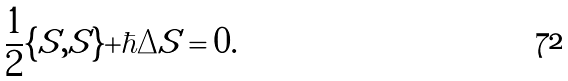Convert formula to latex. <formula><loc_0><loc_0><loc_500><loc_500>\frac { 1 } { 2 } \{ S , S \} + \hbar { \Delta } S = 0 .</formula> 